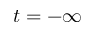Convert formula to latex. <formula><loc_0><loc_0><loc_500><loc_500>t = - \infty</formula> 